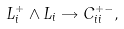Convert formula to latex. <formula><loc_0><loc_0><loc_500><loc_500>L _ { i } ^ { + } \wedge L _ { i } \rightarrow C _ { i i } ^ { + - } ,</formula> 